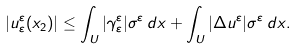<formula> <loc_0><loc_0><loc_500><loc_500>| u _ { \varepsilon } ^ { \varepsilon } ( x _ { 2 } ) | \leq \int _ { U } | \gamma _ { \varepsilon } ^ { \varepsilon } | \sigma ^ { \varepsilon } \, d x + \int _ { U } | \Delta u ^ { \varepsilon } | \sigma ^ { \varepsilon } \, d x .</formula> 